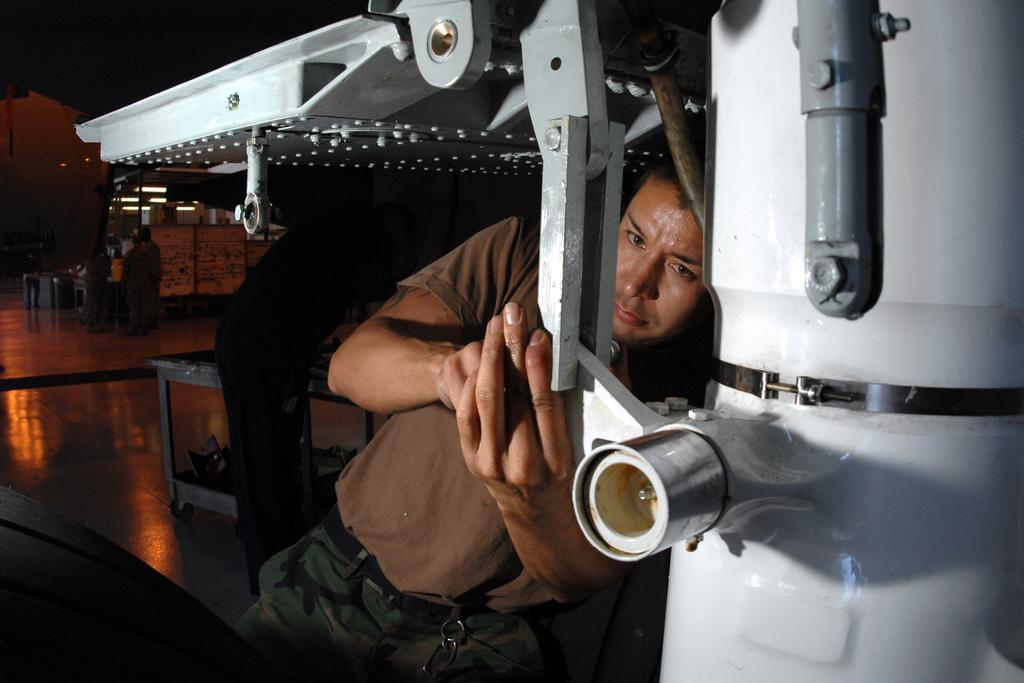What are the people in the image doing? The people in the image are on the floor. What type of objects can be seen in the image? There are metal objects in the image. What can be used to provide illumination in the image? There are lights in the image. How would you describe the overall lighting in the image? The background of the image is dark. What type of elbow is visible in the image? There is no elbow present in the image. What type of school can be seen in the background of the image? There is no school visible in the image; the background is dark. 